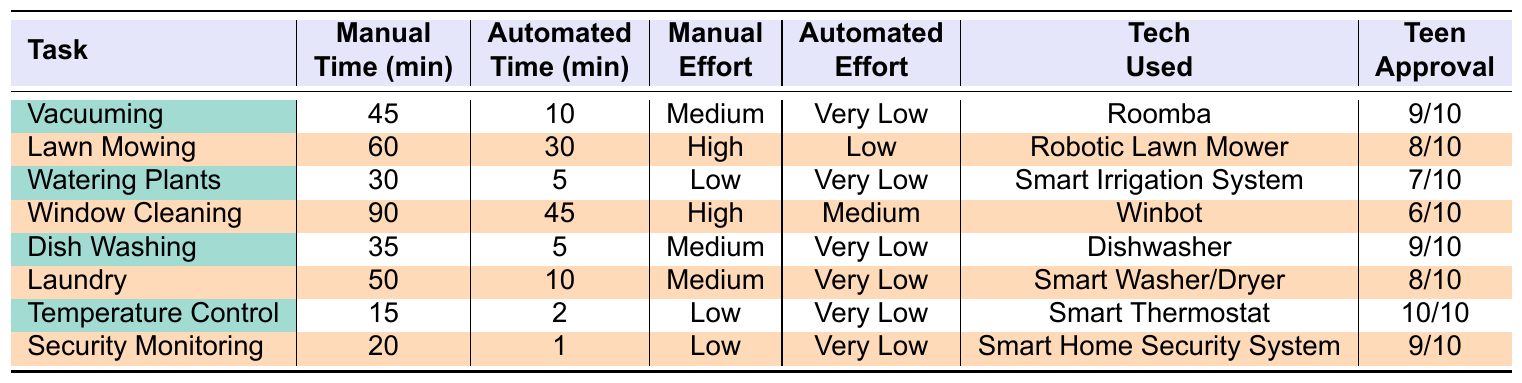What is the manual time spent on window cleaning? The table indicates that the manual time for window cleaning is listed under the "Manual Time (min)" column, specifically for the task of "Window Cleaning." It shows 90 minutes.
Answer: 90 minutes What is the automated time for lawn mowing? For the task of "Lawn Mowing," the automated time is found in the "Automated Time (min)" column, which states 30 minutes.
Answer: 30 minutes Which task has the lowest manual effort level? The manual effort levels are listed in a separate column. The tasks "Watering Plants," "Temperature Control," and "Security Monitoring" are categorized as "Low." However, "Watering Plants" also has the lowest manual time spent at 30 minutes, making it noteworthy to mention.
Answer: Watering Plants, Temperature Control, and Security Monitoring What is the average automated time for all tasks? The automated times for the tasks are: 10, 30, 5, 45, 5, 10, 2, 1. Adding them up gives 10 + 30 + 5 + 45 + 5 + 10 + 2 + 1 = 108 minutes. There are 8 tasks, so the average is 108 / 8 = 13.5 minutes.
Answer: 13.5 minutes Is there a task where automated effort is 'Very Low' while the manual effort is 'High'? In the table, "Lawn Mowing" exhibits a manual effort level of 'High' but has an automated effort level of 'Low.' However, there isn’t an instance where 'Very Low' for automated effort coincides with 'High’ for manual effort.
Answer: No What task has the highest teen approval rating? The teen approval ratings for the tasks are: 9, 8, 7, 6, 9, 8, 10, 9. The highest rating is 10, corresponding to the task "Temperature Control."
Answer: Temperature Control Calculate the difference in manual time between "Laundry" and "Dish Washing." The manual time for "Laundry" is 50 minutes, and for "Dish Washing," it is 35 minutes. The difference is 50 - 35 = 15 minutes.
Answer: 15 minutes What is the total initial cost of the automated technologies listed? The initial costs for the automated technologies are 300, 1000, 200, 400, 500, 1200, 250, 300. Summing these gives 300 + 1000 + 200 + 400 + 500 + 1200 + 250 + 300 = 4150 USD.
Answer: 4150 USD Which task requires the most manual time? By examining the "Manual Time (min)" column, "Window Cleaning" has the highest manual time at 90 minutes, compared to all other tasks.
Answer: Window Cleaning Are there any tasks where the automated time is greater than the manual time? For all tasks, the automated time is less than the manual time. Checking each task confirms that this condition is not met in any case.
Answer: No 